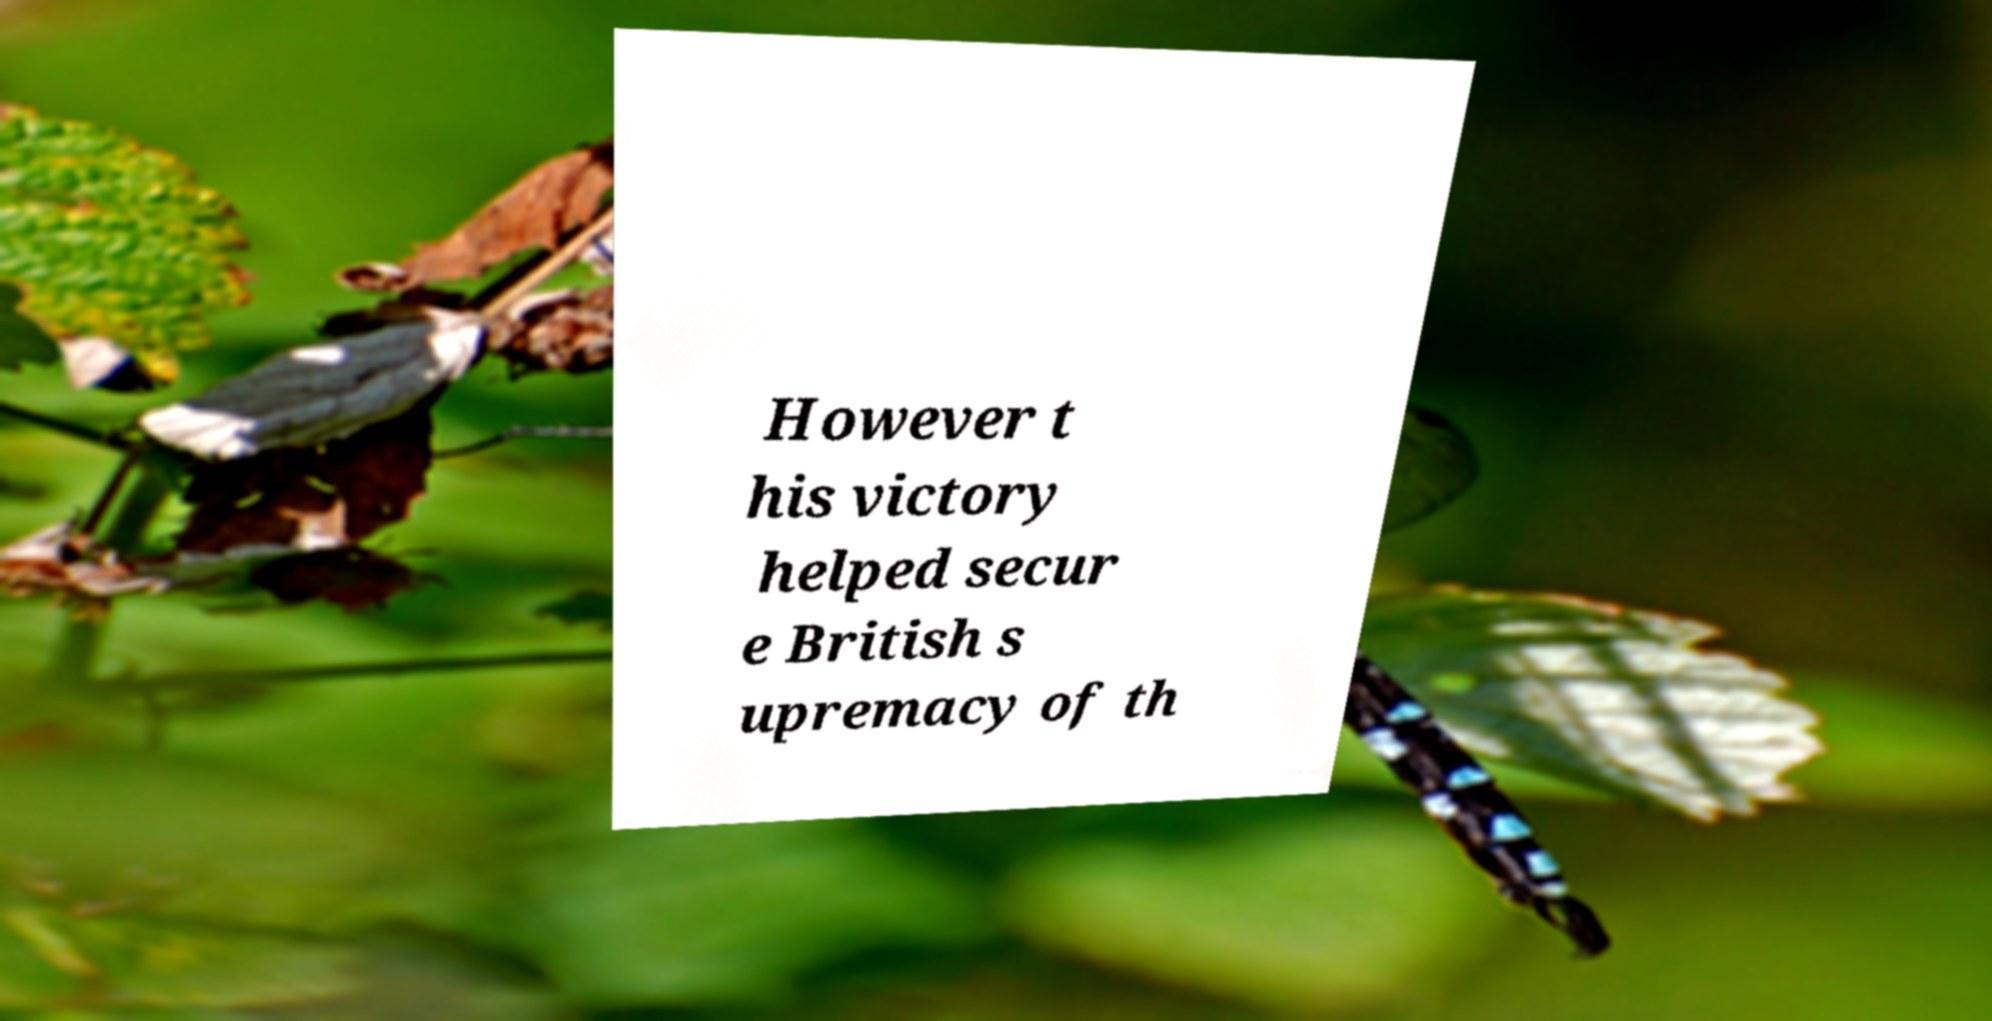Could you assist in decoding the text presented in this image and type it out clearly? However t his victory helped secur e British s upremacy of th 